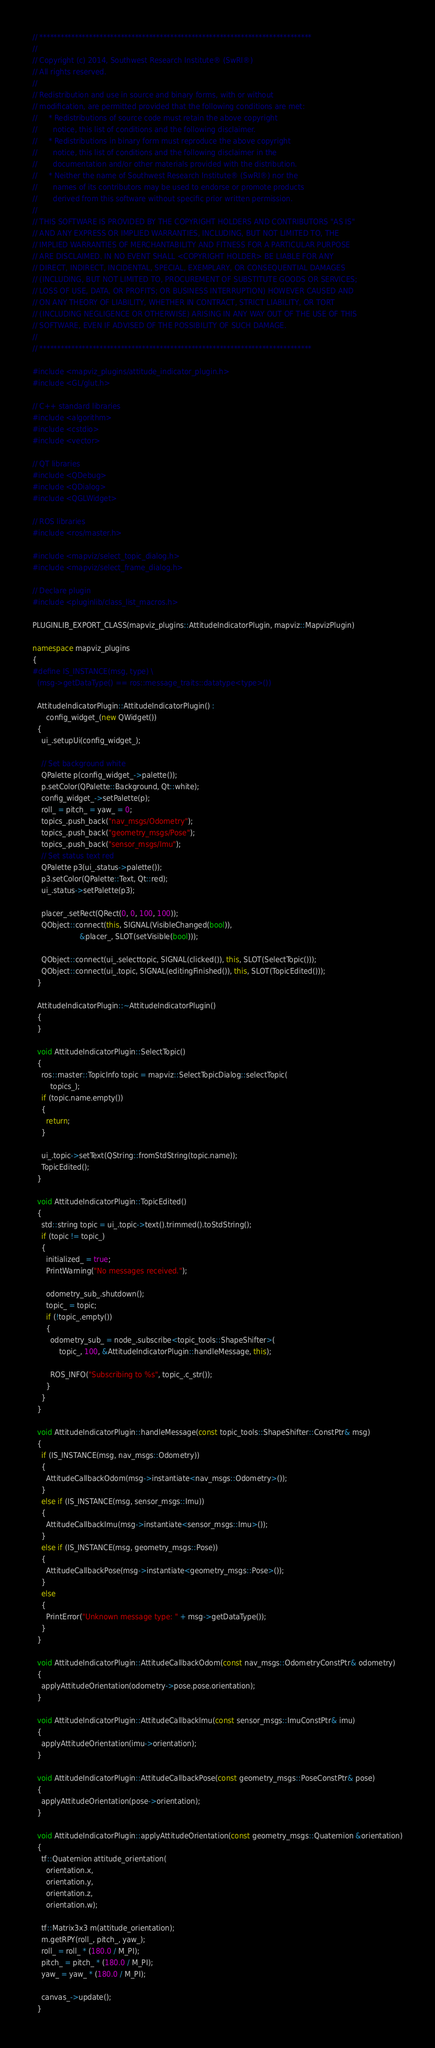<code> <loc_0><loc_0><loc_500><loc_500><_C++_>// *****************************************************************************
//
// Copyright (c) 2014, Southwest Research Institute® (SwRI®)
// All rights reserved.
//
// Redistribution and use in source and binary forms, with or without
// modification, are permitted provided that the following conditions are met:
//     * Redistributions of source code must retain the above copyright
//       notice, this list of conditions and the following disclaimer.
//     * Redistributions in binary form must reproduce the above copyright
//       notice, this list of conditions and the following disclaimer in the
//       documentation and/or other materials provided with the distribution.
//     * Neither the name of Southwest Research Institute® (SwRI®) nor the
//       names of its contributors may be used to endorse or promote products
//       derived from this software without specific prior written permission.
//
// THIS SOFTWARE IS PROVIDED BY THE COPYRIGHT HOLDERS AND CONTRIBUTORS "AS IS"
// AND ANY EXPRESS OR IMPLIED WARRANTIES, INCLUDING, BUT NOT LIMITED TO, THE
// IMPLIED WARRANTIES OF MERCHANTABILITY AND FITNESS FOR A PARTICULAR PURPOSE
// ARE DISCLAIMED. IN NO EVENT SHALL <COPYRIGHT HOLDER> BE LIABLE FOR ANY
// DIRECT, INDIRECT, INCIDENTAL, SPECIAL, EXEMPLARY, OR CONSEQUENTIAL DAMAGES
// (INCLUDING, BUT NOT LIMITED TO, PROCUREMENT OF SUBSTITUTE GOODS OR SERVICES;
// LOSS OF USE, DATA, OR PROFITS; OR BUSINESS INTERRUPTION) HOWEVER CAUSED AND
// ON ANY THEORY OF LIABILITY, WHETHER IN CONTRACT, STRICT LIABILITY, OR TORT
// (INCLUDING NEGLIGENCE OR OTHERWISE) ARISING IN ANY WAY OUT OF THE USE OF THIS
// SOFTWARE, EVEN IF ADVISED OF THE POSSIBILITY OF SUCH DAMAGE.
//
// *****************************************************************************

#include <mapviz_plugins/attitude_indicator_plugin.h>
#include <GL/glut.h>

// C++ standard libraries
#include <algorithm>
#include <cstdio>
#include <vector>

// QT libraries
#include <QDebug>
#include <QDialog>
#include <QGLWidget>

// ROS libraries
#include <ros/master.h>

#include <mapviz/select_topic_dialog.h>
#include <mapviz/select_frame_dialog.h>

// Declare plugin
#include <pluginlib/class_list_macros.h>

PLUGINLIB_EXPORT_CLASS(mapviz_plugins::AttitudeIndicatorPlugin, mapviz::MapvizPlugin)

namespace mapviz_plugins
{
#define IS_INSTANCE(msg, type) \
  (msg->getDataType() == ros::message_traits::datatype<type>())

  AttitudeIndicatorPlugin::AttitudeIndicatorPlugin() :
      config_widget_(new QWidget())
  {
    ui_.setupUi(config_widget_);

    // Set background white
    QPalette p(config_widget_->palette());
    p.setColor(QPalette::Background, Qt::white);
    config_widget_->setPalette(p);
    roll_ = pitch_ = yaw_ = 0;
    topics_.push_back("nav_msgs/Odometry");
    topics_.push_back("geometry_msgs/Pose");
    topics_.push_back("sensor_msgs/Imu");
    // Set status text red
    QPalette p3(ui_.status->palette());
    p3.setColor(QPalette::Text, Qt::red);
    ui_.status->setPalette(p3);

    placer_.setRect(QRect(0, 0, 100, 100));
    QObject::connect(this, SIGNAL(VisibleChanged(bool)),
                     &placer_, SLOT(setVisible(bool)));

    QObject::connect(ui_.selecttopic, SIGNAL(clicked()), this, SLOT(SelectTopic()));
    QObject::connect(ui_.topic, SIGNAL(editingFinished()), this, SLOT(TopicEdited()));
  }

  AttitudeIndicatorPlugin::~AttitudeIndicatorPlugin()
  {
  }

  void AttitudeIndicatorPlugin::SelectTopic()
  {
    ros::master::TopicInfo topic = mapviz::SelectTopicDialog::selectTopic(
        topics_);
    if (topic.name.empty())
    {
      return;
    }

    ui_.topic->setText(QString::fromStdString(topic.name));
    TopicEdited();
  }

  void AttitudeIndicatorPlugin::TopicEdited()
  {
    std::string topic = ui_.topic->text().trimmed().toStdString();
    if (topic != topic_)
    {
      initialized_ = true;
      PrintWarning("No messages received.");

      odometry_sub_.shutdown();
      topic_ = topic;
      if (!topic_.empty())
      {
        odometry_sub_ = node_.subscribe<topic_tools::ShapeShifter>(
            topic_, 100, &AttitudeIndicatorPlugin::handleMessage, this);

        ROS_INFO("Subscribing to %s", topic_.c_str());
      }
    }
  }

  void AttitudeIndicatorPlugin::handleMessage(const topic_tools::ShapeShifter::ConstPtr& msg)
  {
    if (IS_INSTANCE(msg, nav_msgs::Odometry))
    {
      AttitudeCallbackOdom(msg->instantiate<nav_msgs::Odometry>());
    }
    else if (IS_INSTANCE(msg, sensor_msgs::Imu))
    {
      AttitudeCallbackImu(msg->instantiate<sensor_msgs::Imu>());
    }
    else if (IS_INSTANCE(msg, geometry_msgs::Pose))
    {
      AttitudeCallbackPose(msg->instantiate<geometry_msgs::Pose>());
    }
    else
    {
      PrintError("Unknown message type: " + msg->getDataType());
    }
  }

  void AttitudeIndicatorPlugin::AttitudeCallbackOdom(const nav_msgs::OdometryConstPtr& odometry)
  {
    applyAttitudeOrientation(odometry->pose.pose.orientation);
  }

  void AttitudeIndicatorPlugin::AttitudeCallbackImu(const sensor_msgs::ImuConstPtr& imu)
  {
    applyAttitudeOrientation(imu->orientation);
  }

  void AttitudeIndicatorPlugin::AttitudeCallbackPose(const geometry_msgs::PoseConstPtr& pose)
  {
    applyAttitudeOrientation(pose->orientation);
  }

  void AttitudeIndicatorPlugin::applyAttitudeOrientation(const geometry_msgs::Quaternion &orientation)
  {
    tf::Quaternion attitude_orientation(
      orientation.x,
      orientation.y,
      orientation.z,
      orientation.w);

    tf::Matrix3x3 m(attitude_orientation);
    m.getRPY(roll_, pitch_, yaw_);
    roll_ = roll_ * (180.0 / M_PI);
    pitch_ = pitch_ * (180.0 / M_PI);
    yaw_ = yaw_ * (180.0 / M_PI);

    canvas_->update();
  }
</code> 